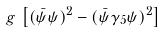<formula> <loc_0><loc_0><loc_500><loc_500>g \, \left [ ( \bar { \psi } \psi ) ^ { 2 } - ( \bar { \psi } \gamma _ { 5 } \psi ) ^ { 2 } \right ] \,</formula> 